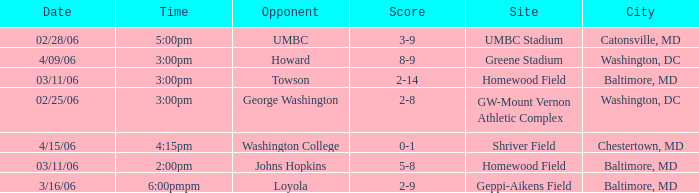Who was the Opponent at Homewood Field with a Score of 5-8? Johns Hopkins. 